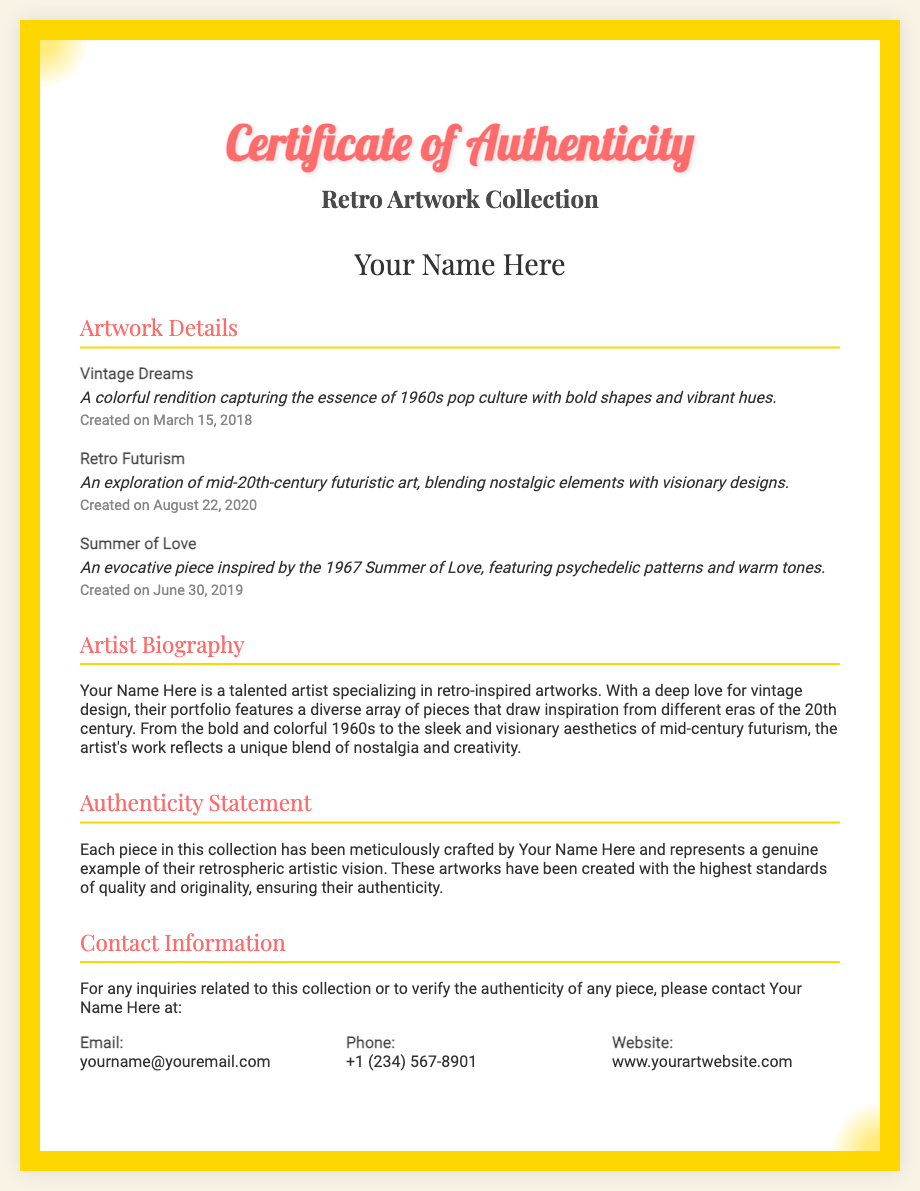what is the title of the document? The title of the document is prominently displayed at the top of the rendered certificate.
Answer: Certificate of Authenticity who is the artist of the Retro Artwork Collection? The artist's name is indicated prominently on the certificate.
Answer: Your Name Here what is the creation date of "Vintage Dreams"? The creation date is specified in the artwork details section.
Answer: March 15, 2018 how many artworks are listed in the certificate? The document lists a specific number of artworks in the "Artwork Details" section.
Answer: Three what theme does the artwork "Summer of Love" represent? The theme can be inferred from the description provided in the artwork details section.
Answer: 1967 Summer of Love which artwork was created on August 22, 2020? This information can be found in the description of the artworks along with their creation dates.
Answer: Retro Futurism what is the contact email for inquiries related to the collection? The email address is provided in the contact information section of the document.
Answer: yourname@youremail.com what statement confirms the authenticity of the artworks? This statement is included in the "Authenticity Statement" section of the certificate.
Answer: a genuine example of their retrospheric artistic vision who can be contacted for verifying the authenticity of the pieces? The document specifies who should be contacted regarding authenticity inquiries.
Answer: Your Name Here 